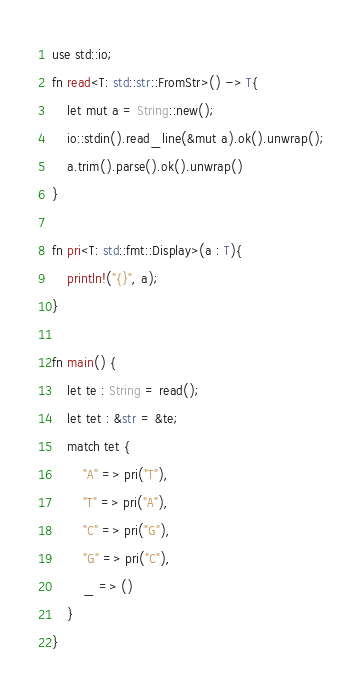Convert code to text. <code><loc_0><loc_0><loc_500><loc_500><_Rust_>use std::io;
fn read<T: std::str::FromStr>() -> T{
    let mut a = String::new();
    io::stdin().read_line(&mut a).ok().unwrap();
    a.trim().parse().ok().unwrap()
}

fn pri<T: std::fmt::Display>(a : T){
    println!("{}", a);
}

fn main() {
    let te : String = read();
    let tet : &str = &te;
    match tet {
        "A" => pri("T"),
        "T" => pri("A"),
        "C" => pri("G"),
        "G" => pri("C"),
        _ => ()
    }
}
</code> 